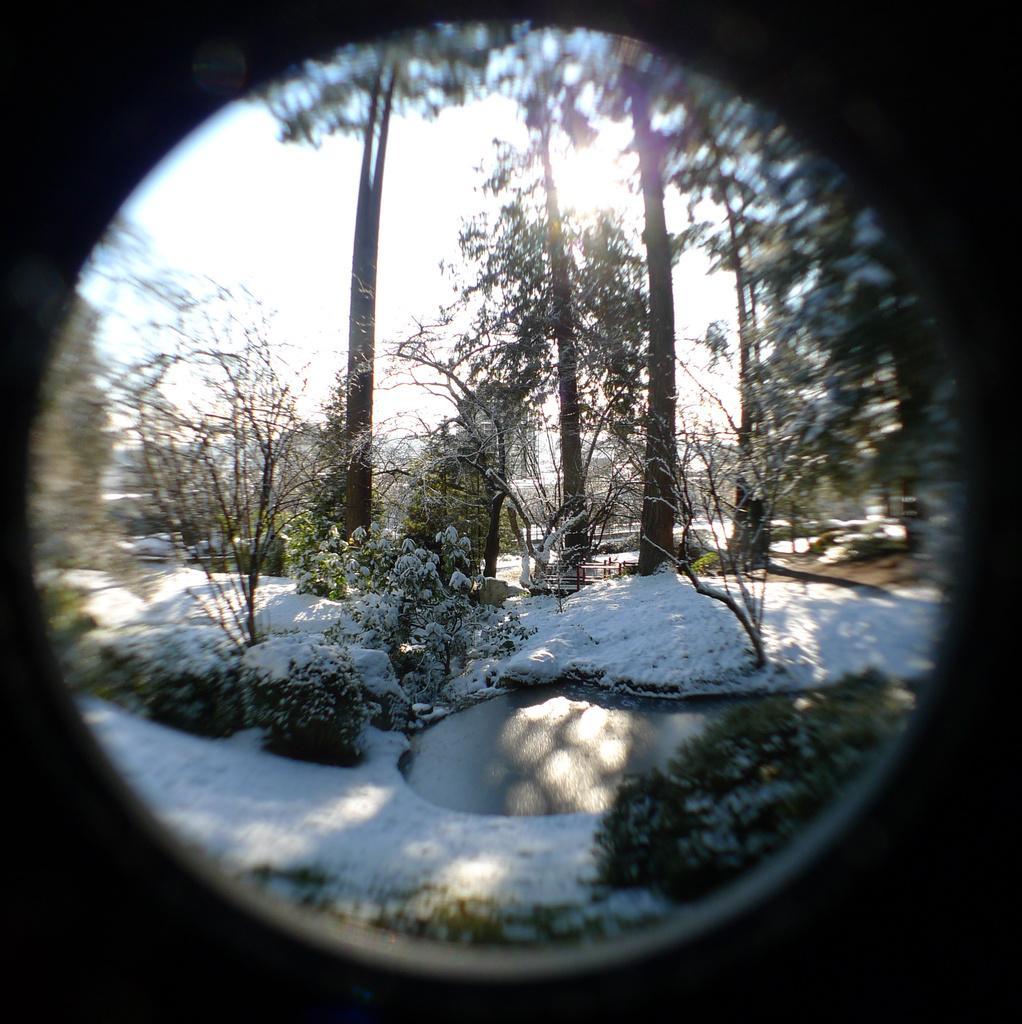Can you describe this image briefly? It looks like a mirror and in on the mirror we can see the reflections of snow, plants, trees and water. Behind the trees there is the sky. 